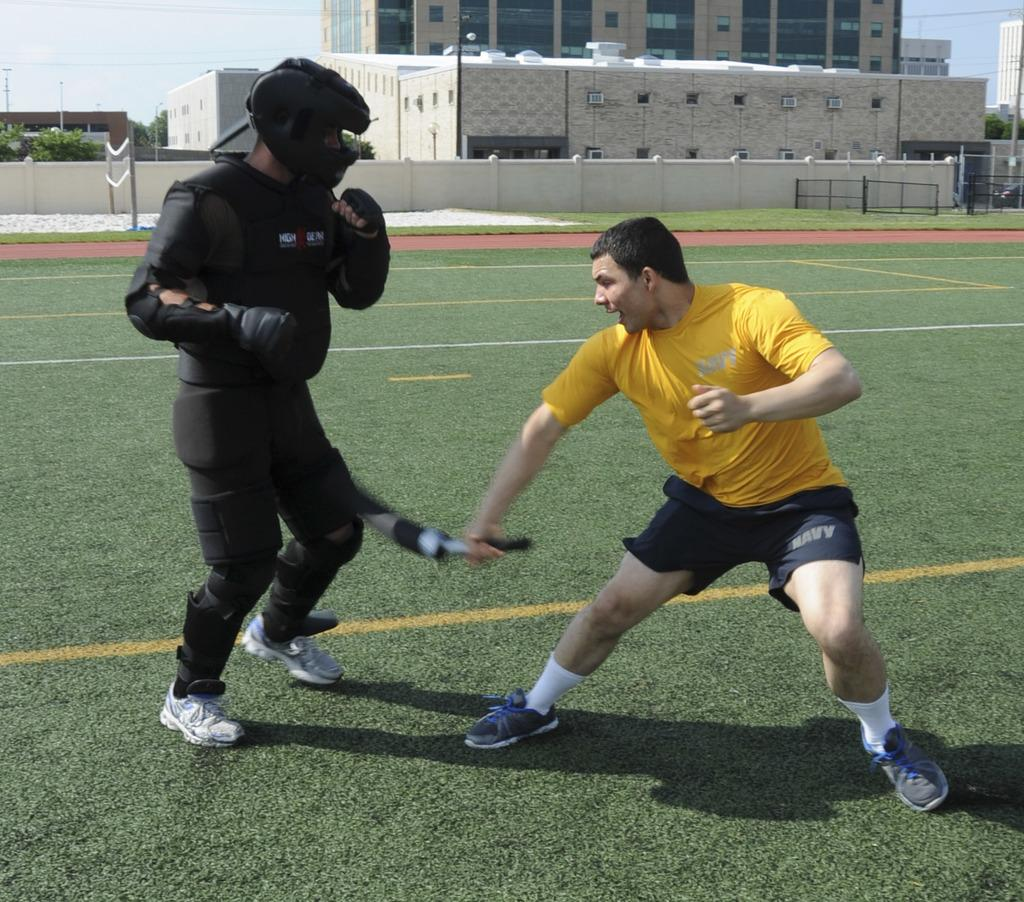Provide a one-sentence caption for the provided image. A boy is fencing with another man and is wearing shorts that say Navy. 